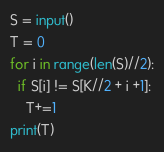Convert code to text. <code><loc_0><loc_0><loc_500><loc_500><_Python_>S = input()
T = 0
for i in range(len(S)//2):
  if S[i] != S[K//2 + i +1]:
    T+=1
print(T)</code> 